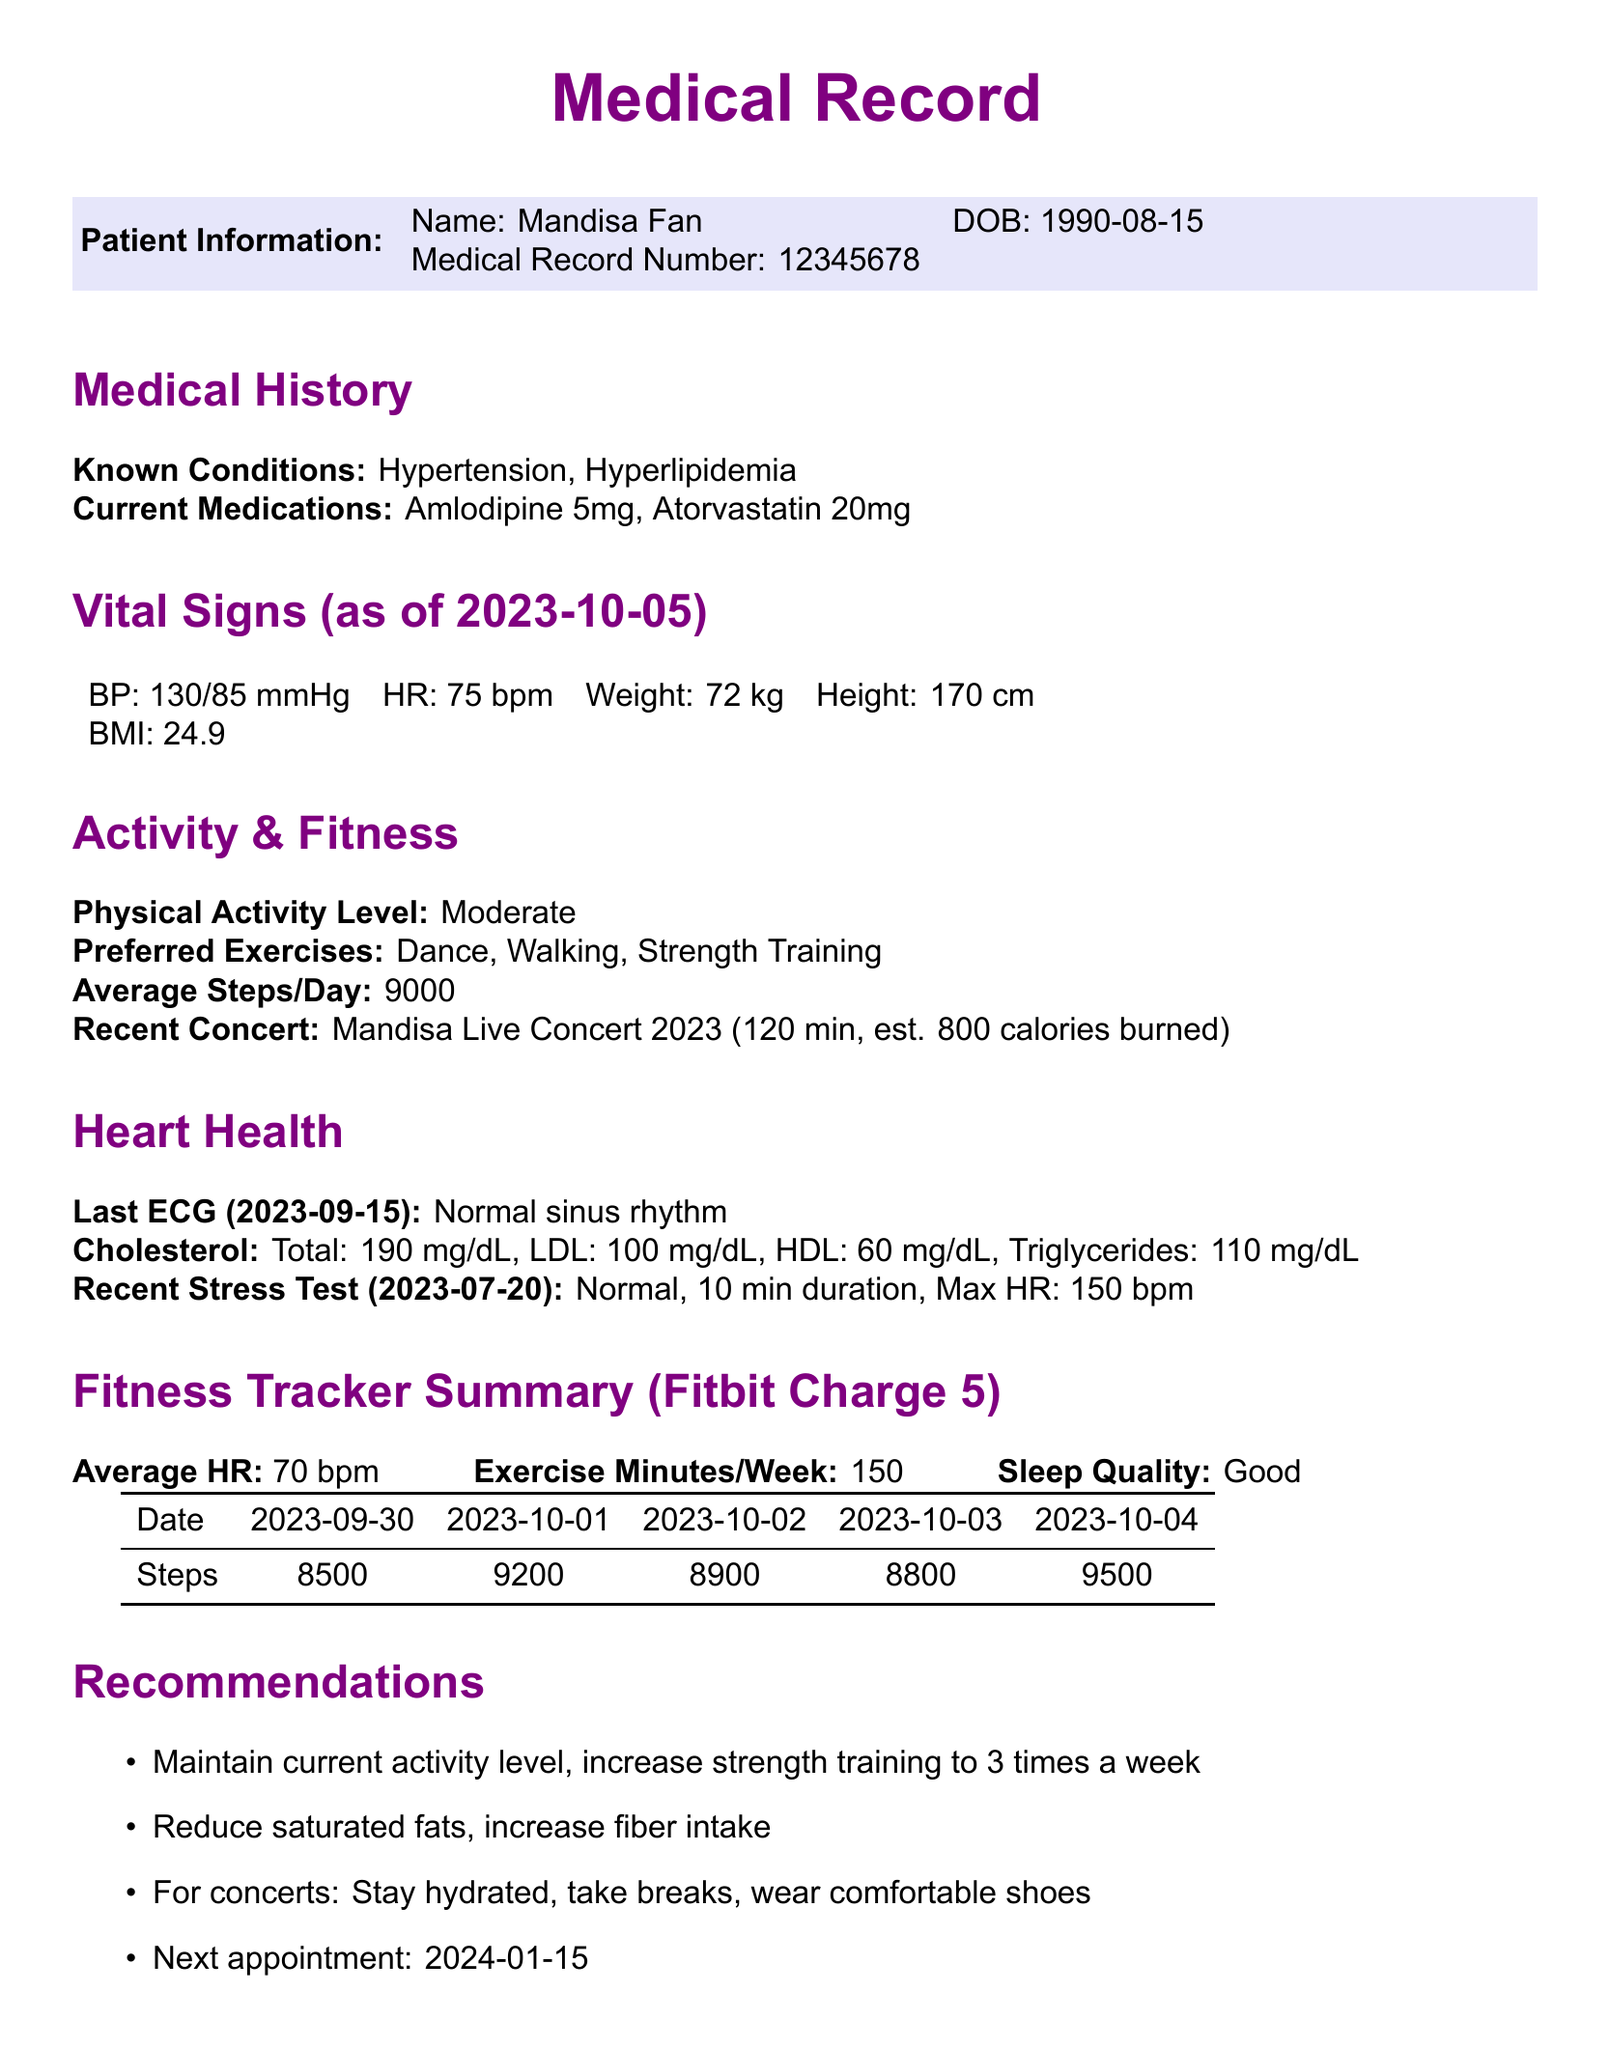What is the patient's date of birth? The patient's date of birth is stated in the patient information section of the document.
Answer: 1990-08-15 What is the current medication for hypertension? The document lists the current medications, including specific medications for hypertension.
Answer: Amlodipine 5mg What was the last ECG result? The heart health section provides details about the last ECG performed on the patient.
Answer: Normal sinus rhythm What is the average heart rate mentioned in the fitness tracker summary? The fitness tracker summary includes the average heart rate recorded for the patient.
Answer: 70 bpm What is the suggested number of exercise minutes per week? The fitness tracker summary indicates the recommended exercise duration in minutes for the patient per week.
Answer: 150 What was the maximum heart rate recorded in the recent stress test? The heart health section discusses the results of the recent stress test, including the maximum heart rate achieved.
Answer: 150 bpm What should the patient increase to three times a week? The recommendations portion suggests a frequency for certain types of exercises that the patient should increase.
Answer: Strength training When is the next appointment scheduled? The recommendations section specifies the date of the next appointment for the patient.
Answer: 2024-01-15 What concert did the patient recently attend? The activity and fitness section notes the recent concert attended by the patient and its duration.
Answer: Mandisa Live Concert 2023 